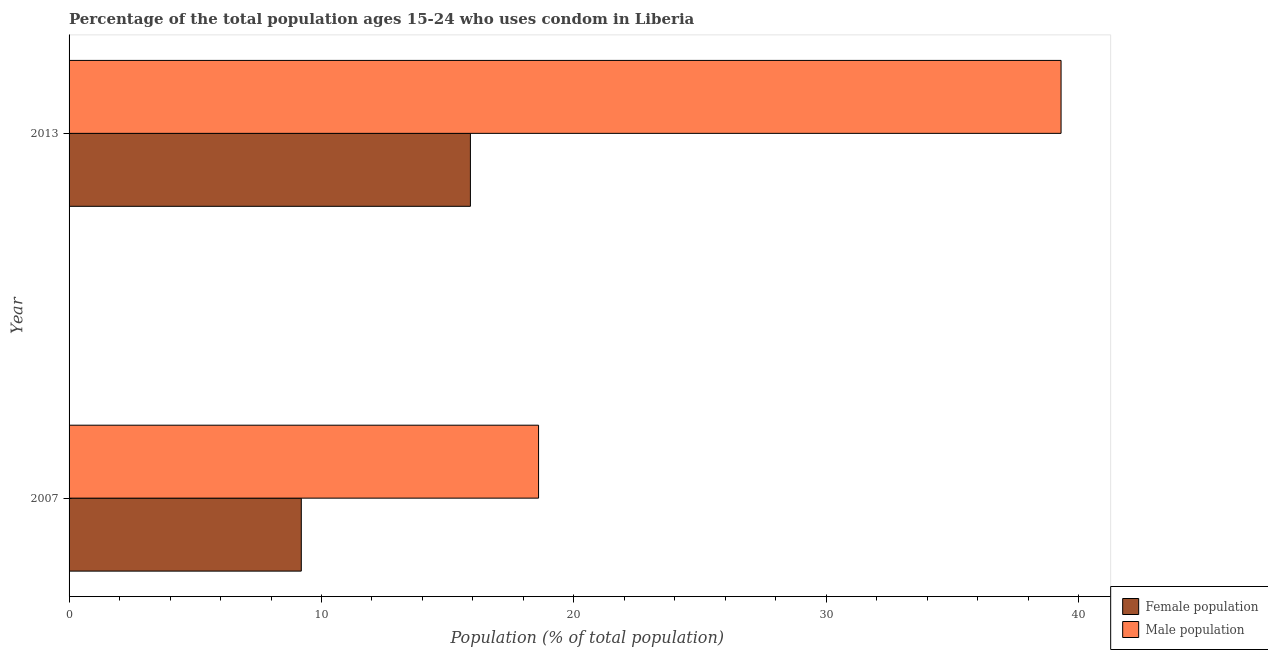How many groups of bars are there?
Provide a succinct answer. 2. Are the number of bars per tick equal to the number of legend labels?
Your answer should be compact. Yes. Are the number of bars on each tick of the Y-axis equal?
Ensure brevity in your answer.  Yes. How many bars are there on the 1st tick from the top?
Give a very brief answer. 2. How many bars are there on the 2nd tick from the bottom?
Make the answer very short. 2. What is the label of the 2nd group of bars from the top?
Your answer should be very brief. 2007. Across all years, what is the minimum male population?
Keep it short and to the point. 18.6. In which year was the male population minimum?
Provide a succinct answer. 2007. What is the total male population in the graph?
Provide a short and direct response. 57.9. What is the difference between the female population in 2007 and the male population in 2013?
Keep it short and to the point. -30.1. What is the average male population per year?
Offer a terse response. 28.95. In the year 2013, what is the difference between the female population and male population?
Your answer should be compact. -23.4. In how many years, is the female population greater than 32 %?
Provide a succinct answer. 0. What is the ratio of the female population in 2007 to that in 2013?
Keep it short and to the point. 0.58. Is the difference between the male population in 2007 and 2013 greater than the difference between the female population in 2007 and 2013?
Your answer should be compact. No. In how many years, is the male population greater than the average male population taken over all years?
Your answer should be compact. 1. What does the 1st bar from the top in 2007 represents?
Offer a very short reply. Male population. What does the 2nd bar from the bottom in 2007 represents?
Offer a terse response. Male population. Are all the bars in the graph horizontal?
Keep it short and to the point. Yes. What is the difference between two consecutive major ticks on the X-axis?
Make the answer very short. 10. Are the values on the major ticks of X-axis written in scientific E-notation?
Ensure brevity in your answer.  No. Does the graph contain any zero values?
Your answer should be compact. No. How many legend labels are there?
Give a very brief answer. 2. What is the title of the graph?
Your response must be concise. Percentage of the total population ages 15-24 who uses condom in Liberia. What is the label or title of the X-axis?
Your answer should be very brief. Population (% of total population) . What is the label or title of the Y-axis?
Give a very brief answer. Year. What is the Population (% of total population)  in Female population in 2007?
Provide a succinct answer. 9.2. What is the Population (% of total population)  in Male population in 2013?
Your response must be concise. 39.3. Across all years, what is the maximum Population (% of total population)  of Male population?
Your answer should be very brief. 39.3. What is the total Population (% of total population)  of Female population in the graph?
Ensure brevity in your answer.  25.1. What is the total Population (% of total population)  of Male population in the graph?
Keep it short and to the point. 57.9. What is the difference between the Population (% of total population)  of Male population in 2007 and that in 2013?
Give a very brief answer. -20.7. What is the difference between the Population (% of total population)  of Female population in 2007 and the Population (% of total population)  of Male population in 2013?
Give a very brief answer. -30.1. What is the average Population (% of total population)  of Female population per year?
Offer a terse response. 12.55. What is the average Population (% of total population)  in Male population per year?
Keep it short and to the point. 28.95. In the year 2013, what is the difference between the Population (% of total population)  of Female population and Population (% of total population)  of Male population?
Offer a very short reply. -23.4. What is the ratio of the Population (% of total population)  of Female population in 2007 to that in 2013?
Offer a terse response. 0.58. What is the ratio of the Population (% of total population)  of Male population in 2007 to that in 2013?
Ensure brevity in your answer.  0.47. What is the difference between the highest and the second highest Population (% of total population)  in Male population?
Keep it short and to the point. 20.7. What is the difference between the highest and the lowest Population (% of total population)  in Male population?
Provide a short and direct response. 20.7. 